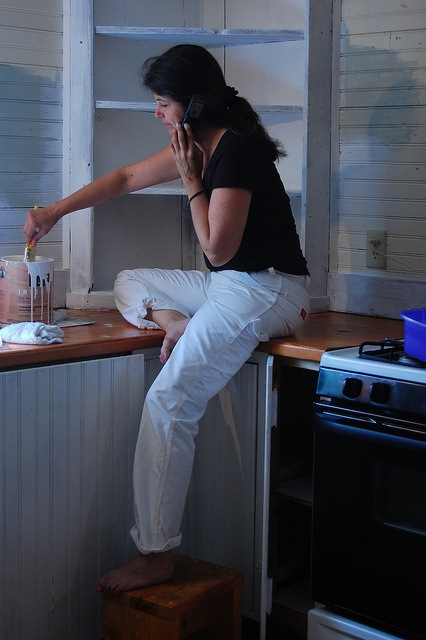Describe the objects in this image and their specific colors. I can see people in gray, black, and darkgray tones, oven in gray, black, navy, blue, and lightblue tones, and cell phone in gray, black, navy, and blue tones in this image. 